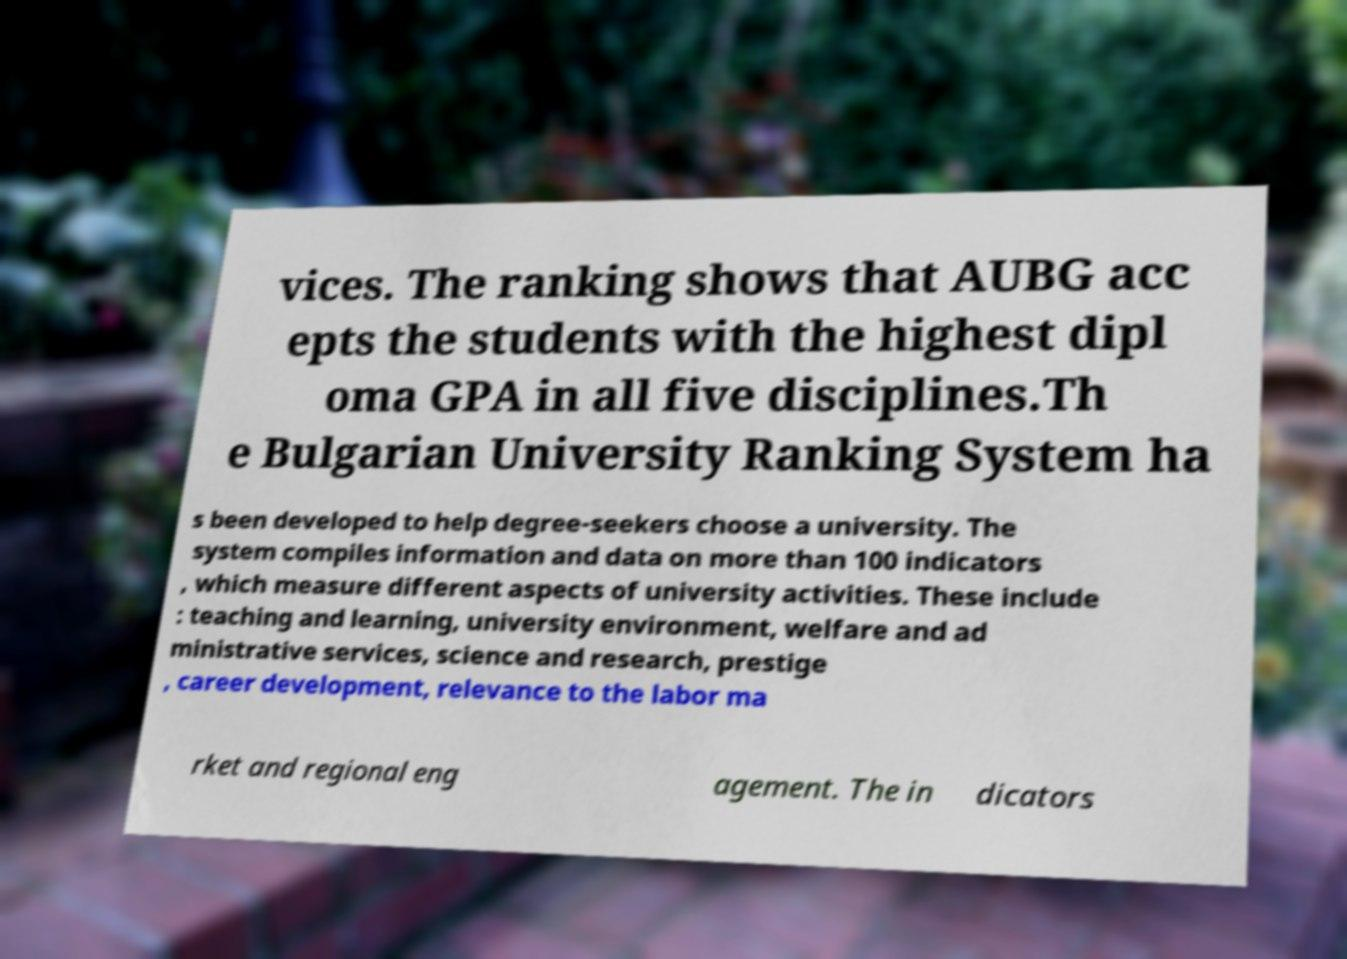Please identify and transcribe the text found in this image. vices. The ranking shows that AUBG acc epts the students with the highest dipl oma GPA in all five disciplines.Th e Bulgarian University Ranking System ha s been developed to help degree-seekers choose a university. The system compiles information and data on more than 100 indicators , which measure different aspects of university activities. These include : teaching and learning, university environment, welfare and ad ministrative services, science and research, prestige , career development, relevance to the labor ma rket and regional eng agement. The in dicators 